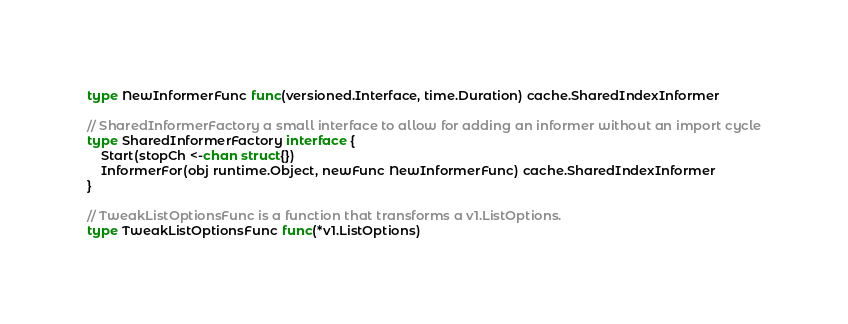<code> <loc_0><loc_0><loc_500><loc_500><_Go_>type NewInformerFunc func(versioned.Interface, time.Duration) cache.SharedIndexInformer

// SharedInformerFactory a small interface to allow for adding an informer without an import cycle
type SharedInformerFactory interface {
	Start(stopCh <-chan struct{})
	InformerFor(obj runtime.Object, newFunc NewInformerFunc) cache.SharedIndexInformer
}

// TweakListOptionsFunc is a function that transforms a v1.ListOptions.
type TweakListOptionsFunc func(*v1.ListOptions)
</code> 